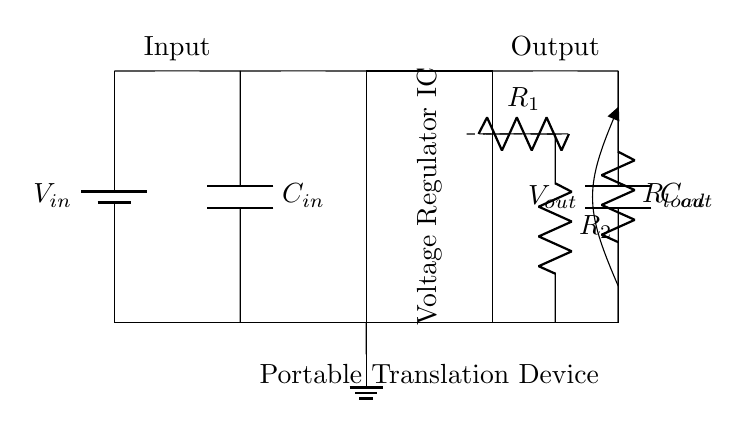What is the function of the voltage regulator IC? The voltage regulator IC stabilizes the output voltage, ensuring it remains at a desired level despite variations in input voltage or load current.
Answer: stabilizes output voltage What are the values of the feedback resistors? In the circuit, there are two feedback resistors labeled R1 and R2, which set the output voltage through a resistive divider configuration.
Answer: R1 and R2 What is the role of the input capacitor? The input capacitor, C_in, filters the input voltage to smooth out fluctuations and provides a stable voltage to the voltage regulator IC.
Answer: smoothing input voltage What voltage is provided at the output? The output voltage V_out is indicated on the circuit, which is the regulated output provided to the load.
Answer: V_out How is the load connected in this circuit? The load is connected in parallel to the output capacitor, with a resistor labeled R_load, representing the load consuming the regulated voltage.
Answer: in parallel What happens if the input voltage exceeds the specified range? If the input voltage exceeds the specified range, the voltage regulator may go into overvoltage protection, potentially shutting down or limiting the output voltage.
Answer: overvoltage protection Which component is responsible for providing voltage stability? The component responsible for providing voltage stability in the circuit is the voltage regulator IC, as it adjusts the output based on feedback received.
Answer: voltage regulator IC 